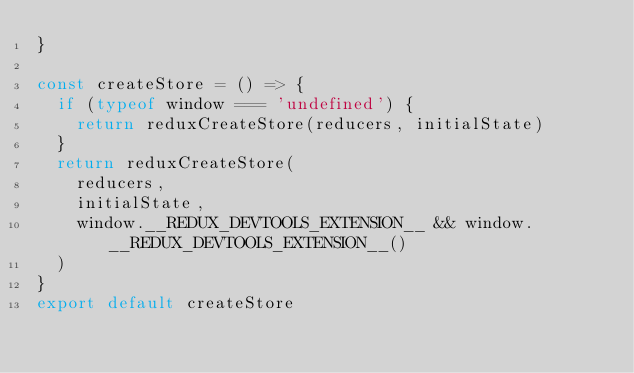<code> <loc_0><loc_0><loc_500><loc_500><_JavaScript_>}

const createStore = () => {
  if (typeof window === 'undefined') {
    return reduxCreateStore(reducers, initialState)
  }
  return reduxCreateStore(
    reducers,
    initialState,
    window.__REDUX_DEVTOOLS_EXTENSION__ && window.__REDUX_DEVTOOLS_EXTENSION__()
  )
}
export default createStore
</code> 